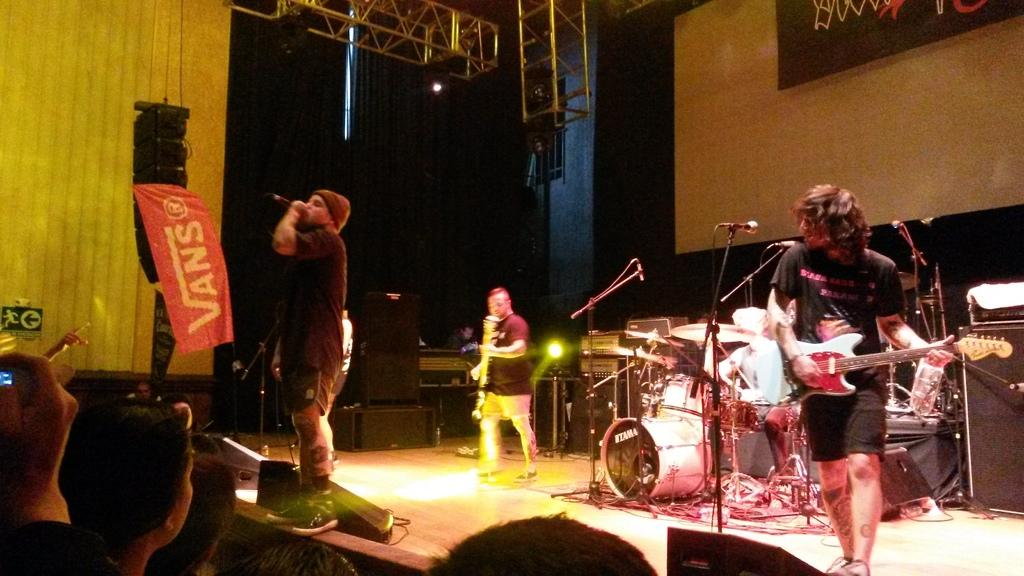What are the musicians in the image doing? There are two men playing guitar, one man playing drums, and one man singing with a microphone in the image. What is the audience in the image doing? The audience is watching the performers in the image. What type of plastic material can be seen in the image? There is no plastic material visible in the image. How many muscles does the singer have in the image? The number of muscles a person has cannot be determined from an image alone, and there is no specific focus on the singer's muscles in this image. 